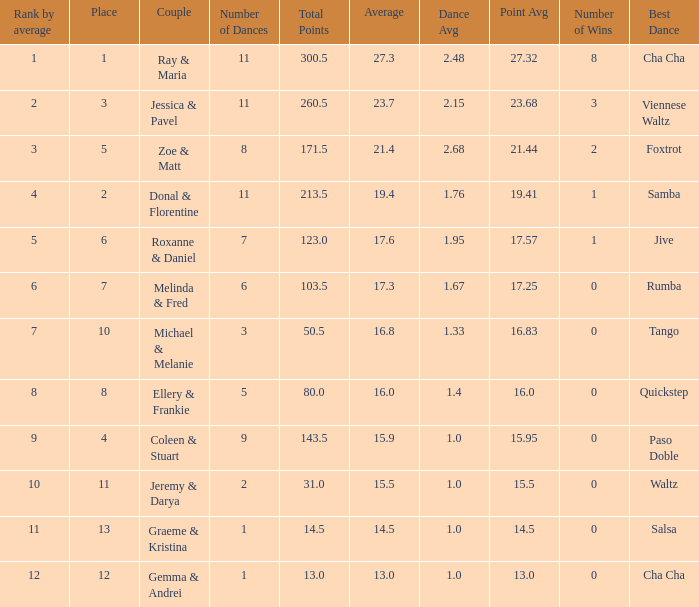What is the couples name where the average is 15.9? Coleen & Stuart. 